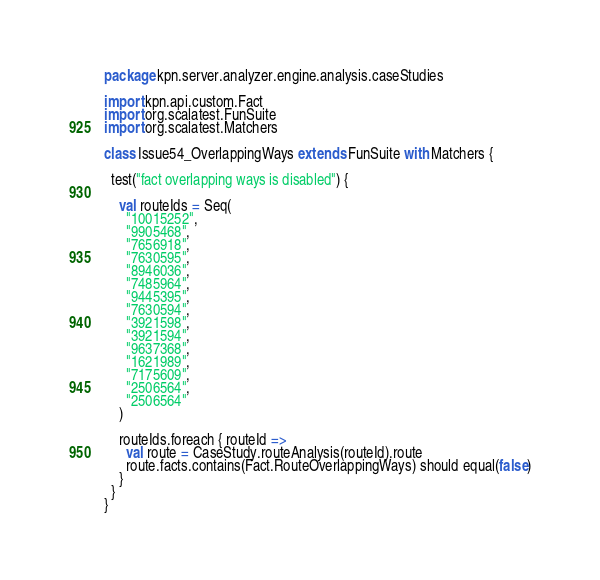<code> <loc_0><loc_0><loc_500><loc_500><_Scala_>package kpn.server.analyzer.engine.analysis.caseStudies

import kpn.api.custom.Fact
import org.scalatest.FunSuite
import org.scalatest.Matchers

class Issue54_OverlappingWays extends FunSuite with Matchers {

  test("fact overlapping ways is disabled") {

    val routeIds = Seq(
      "10015252",
      "9905468",
      "7656918",
      "7630595",
      "8946036",
      "7485964",
      "9445395",
      "7630594",
      "3921598",
      "3921594",
      "9637368",
      "1621989",
      "7175609",
      "2506564",
      "2506564"
    )

    routeIds.foreach { routeId =>
      val route = CaseStudy.routeAnalysis(routeId).route
      route.facts.contains(Fact.RouteOverlappingWays) should equal(false)
    }
  }
}
</code> 